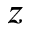<formula> <loc_0><loc_0><loc_500><loc_500>z</formula> 